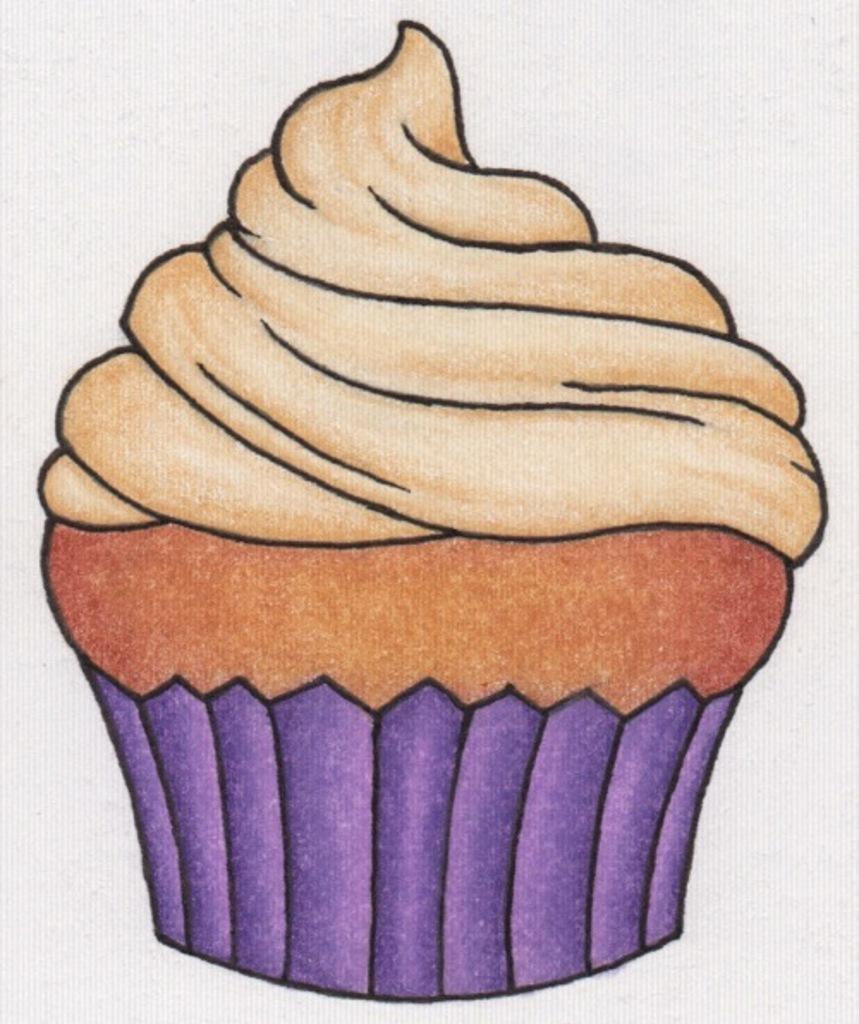Describe this image in one or two sentences. In this image, we can see a painting of a cupcake. In the background, we can see white color. 